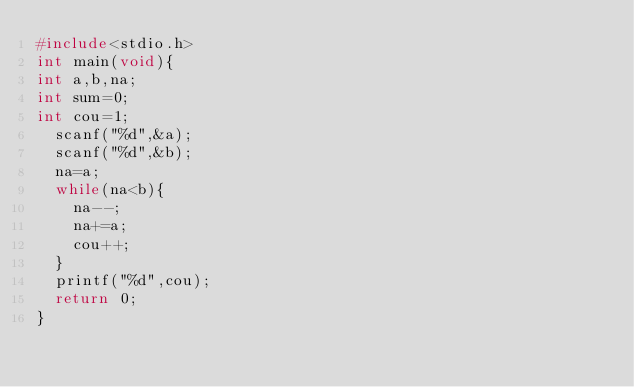Convert code to text. <code><loc_0><loc_0><loc_500><loc_500><_C_>#include<stdio.h>
int main(void){
int a,b,na;
int sum=0;
int cou=1;
  scanf("%d",&a);
  scanf("%d",&b);
  na=a;
  while(na<b){
    na--;
    na+=a;
    cou++;
  }
  printf("%d",cou);
  return 0;
}</code> 